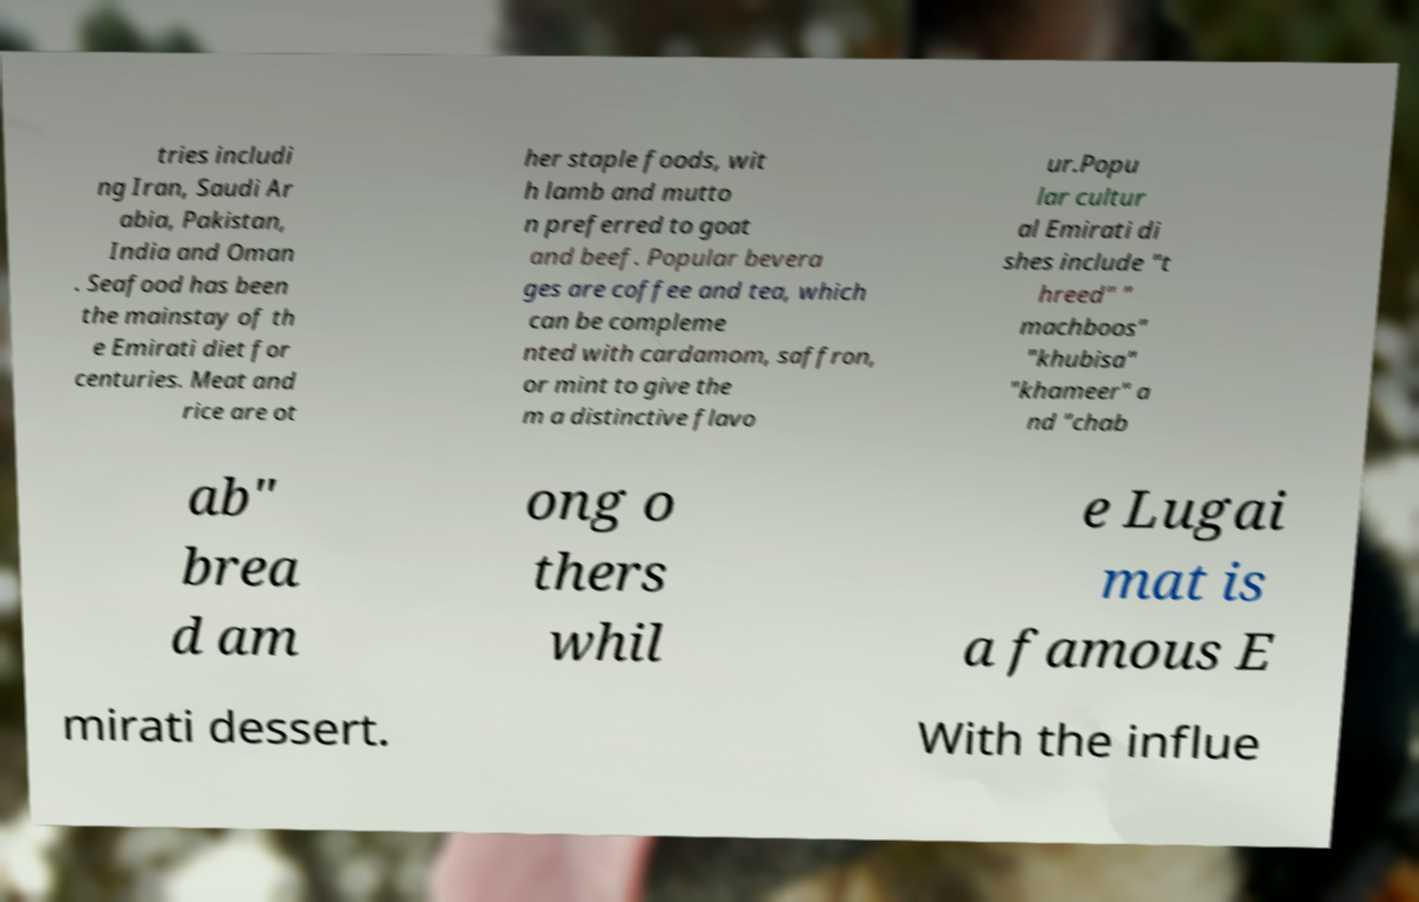Please read and relay the text visible in this image. What does it say? tries includi ng Iran, Saudi Ar abia, Pakistan, India and Oman . Seafood has been the mainstay of th e Emirati diet for centuries. Meat and rice are ot her staple foods, wit h lamb and mutto n preferred to goat and beef. Popular bevera ges are coffee and tea, which can be compleme nted with cardamom, saffron, or mint to give the m a distinctive flavo ur.Popu lar cultur al Emirati di shes include "t hreed" " machboos" "khubisa" "khameer" a nd "chab ab" brea d am ong o thers whil e Lugai mat is a famous E mirati dessert. With the influe 